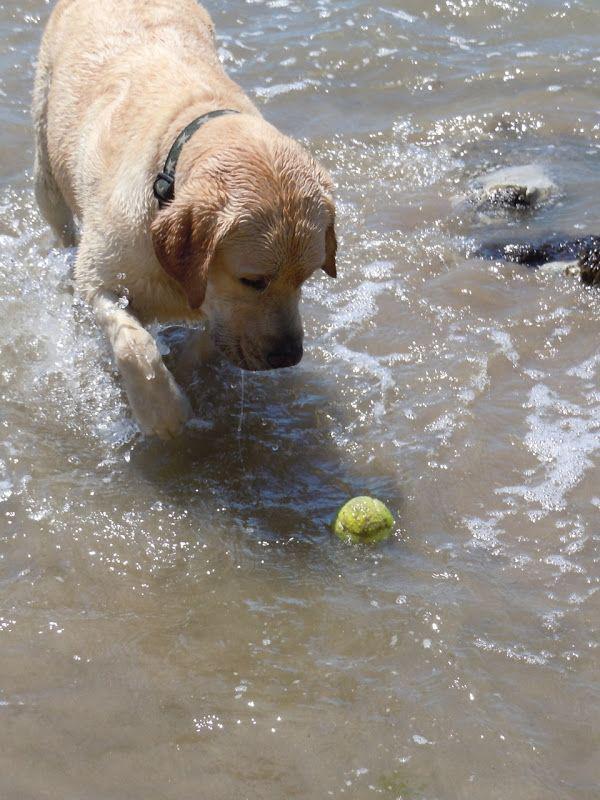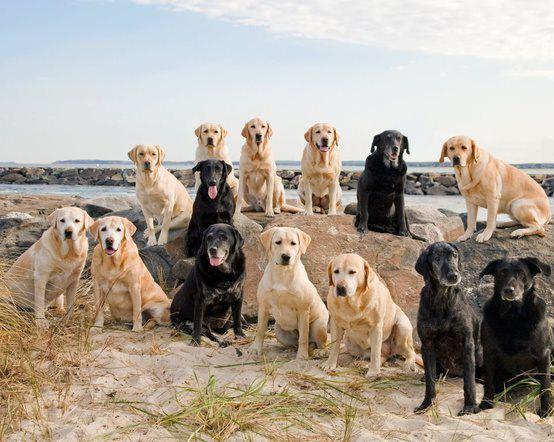The first image is the image on the left, the second image is the image on the right. Examine the images to the left and right. Is the description "One of the images features a dog standing in liquid water." accurate? Answer yes or no. Yes. The first image is the image on the left, the second image is the image on the right. Given the left and right images, does the statement "There are no more than two animals." hold true? Answer yes or no. No. 